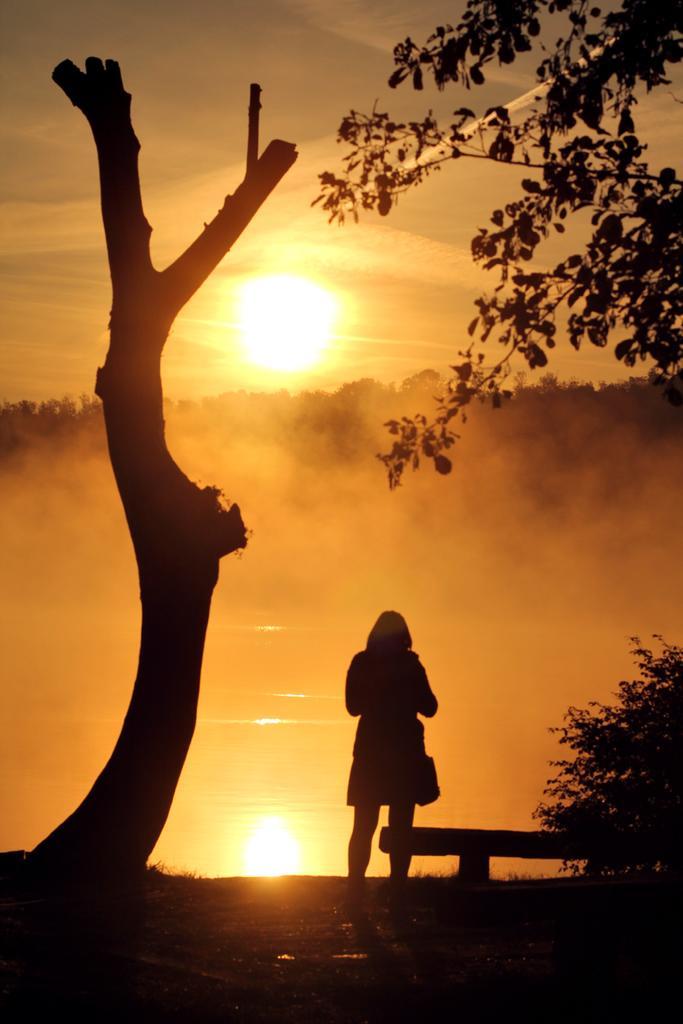In one or two sentences, can you explain what this image depicts? In the middle a woman is standing, on the right side, there are trees. In the middle it is the sun. At the bottom there is water. 